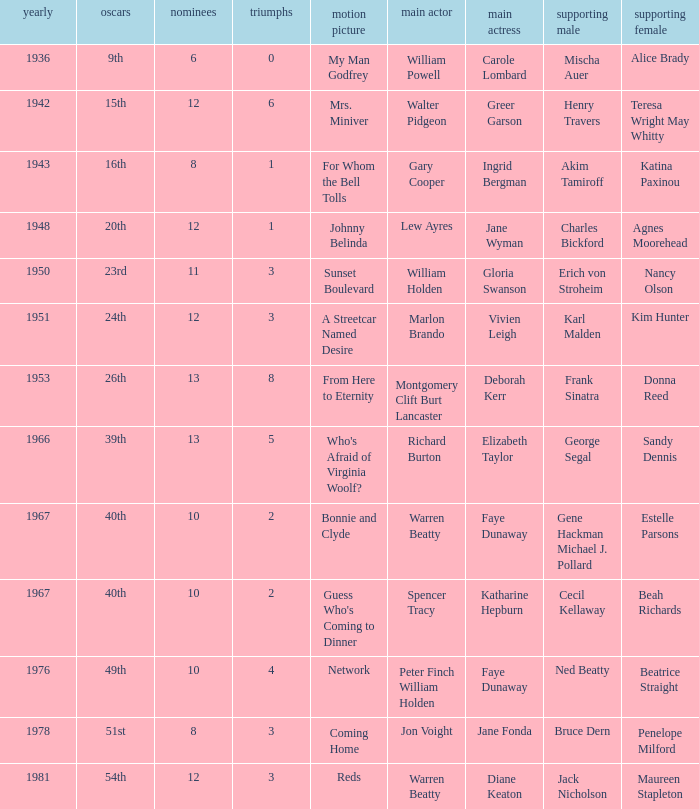Which motion picture included charles bickford as a supporting performer? Johnny Belinda. 